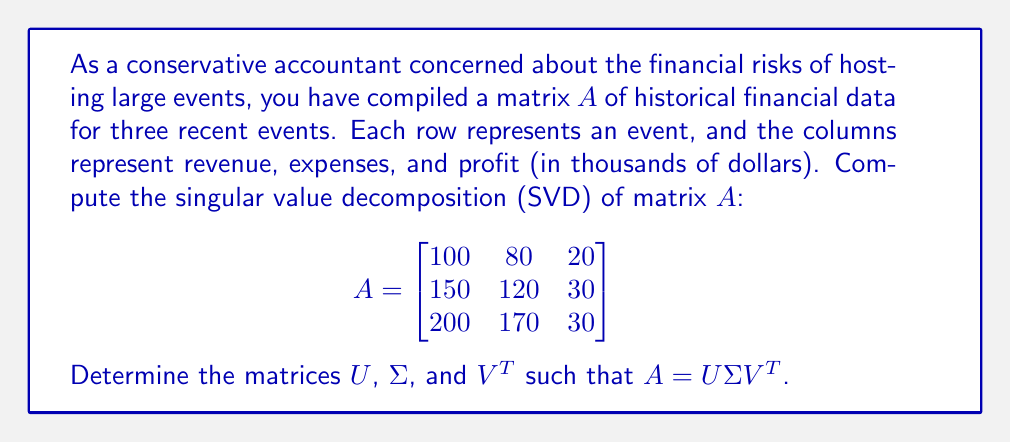Solve this math problem. To compute the singular value decomposition of matrix $A$, we follow these steps:

1) First, calculate $A^TA$:
   $$A^TA = \begin{bmatrix}
   100 & 150 & 200 \\
   80 & 120 & 170 \\
   20 & 30 & 30
   \end{bmatrix} \begin{bmatrix}
   100 & 80 & 20 \\
   150 & 120 & 30 \\
   200 & 170 & 30
   \end{bmatrix} = \begin{bmatrix}
   70500 & 57400 & 11300 \\
   57400 & 46900 & 9200 \\
   11300 & 9200 & 1800
   \end{bmatrix}$$

2) Find the eigenvalues of $A^TA$ by solving $\det(A^TA - \lambda I) = 0$:
   $$\det\begin{vmatrix}
   70500-\lambda & 57400 & 11300 \\
   57400 & 46900-\lambda & 9200 \\
   11300 & 9200 & 1800-\lambda
   \end{vmatrix} = 0$$
   
   This yields the characteristic equation:
   $$-\lambda^3 + 119200\lambda^2 - 7560000\lambda + 0 = 0$$
   
   Solving this equation gives us the eigenvalues:
   $$\lambda_1 \approx 118964.73, \lambda_2 \approx 235.27, \lambda_3 = 0$$

3) The singular values are the square roots of these eigenvalues:
   $$\sigma_1 \approx 344.91, \sigma_2 \approx 15.34, \sigma_3 = 0$$

4) To find $V$, we need to find the eigenvectors of $A^TA$ corresponding to these eigenvalues. After normalization, we get:
   $$V \approx \begin{bmatrix}
   0.8165 & -0.5736 & 0.0627 \\
   0.5682 & 0.8192 & -0.0734 \\
   0.1049 & 0.0207 & 0.9943
   \end{bmatrix}$$

5) To find $U$, we can use the relation $AV = U\Sigma$. Multiply $A$ by each column of $V$ and normalize:
   $$U \approx \begin{bmatrix}
   0.3780 & -0.7682 & 0.5164 \\
   0.5669 & -0.0385 & -0.8229 \\
   0.7307 & 0.6391 & 0.2391
   \end{bmatrix}$$

6) Finally, $\Sigma$ is a 3x3 diagonal matrix with singular values on the diagonal:
   $$\Sigma \approx \begin{bmatrix}
   344.91 & 0 & 0 \\
   0 & 15.34 & 0 \\
   0 & 0 & 0
   \end{bmatrix}$$
Answer: $U \approx \begin{bmatrix}
0.3780 & -0.7682 & 0.5164 \\
0.5669 & -0.0385 & -0.8229 \\
0.7307 & 0.6391 & 0.2391
\end{bmatrix}$, 
$\Sigma \approx \begin{bmatrix}
344.91 & 0 & 0 \\
0 & 15.34 & 0 \\
0 & 0 & 0
\end{bmatrix}$, 
$V^T \approx \begin{bmatrix}
0.8165 & 0.5682 & 0.1049 \\
-0.5736 & 0.8192 & 0.0207 \\
0.0627 & -0.0734 & 0.9943
\end{bmatrix}$ 